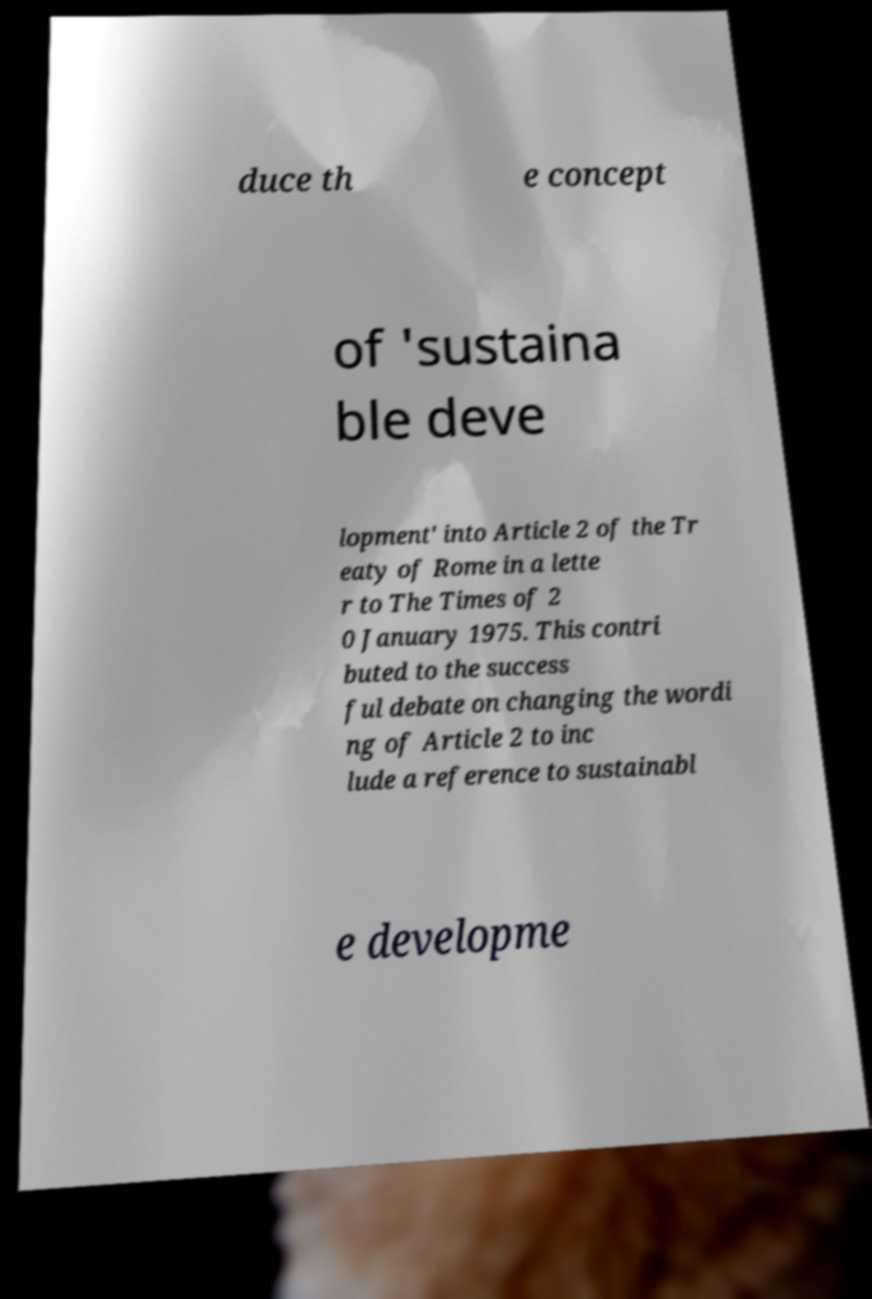There's text embedded in this image that I need extracted. Can you transcribe it verbatim? duce th e concept of 'sustaina ble deve lopment' into Article 2 of the Tr eaty of Rome in a lette r to The Times of 2 0 January 1975. This contri buted to the success ful debate on changing the wordi ng of Article 2 to inc lude a reference to sustainabl e developme 